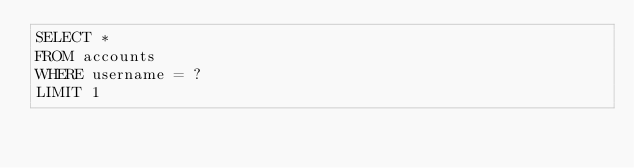Convert code to text. <code><loc_0><loc_0><loc_500><loc_500><_SQL_>SELECT * 
FROM accounts
WHERE username = ?
LIMIT 1</code> 